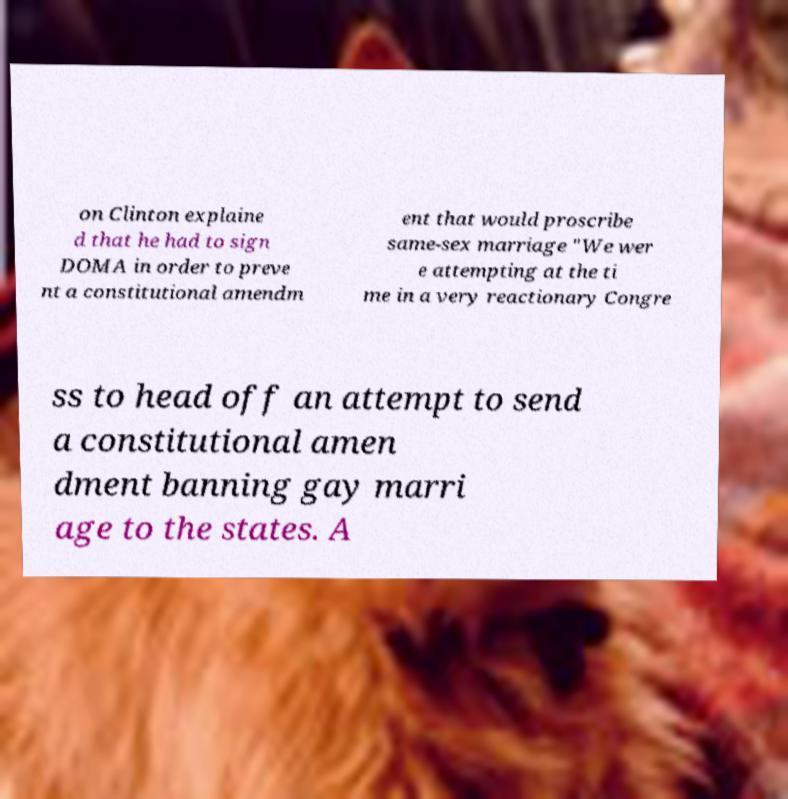Can you read and provide the text displayed in the image?This photo seems to have some interesting text. Can you extract and type it out for me? on Clinton explaine d that he had to sign DOMA in order to preve nt a constitutional amendm ent that would proscribe same-sex marriage "We wer e attempting at the ti me in a very reactionary Congre ss to head off an attempt to send a constitutional amen dment banning gay marri age to the states. A 